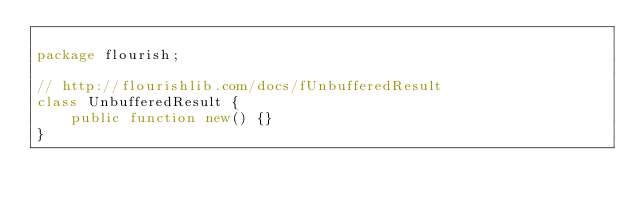<code> <loc_0><loc_0><loc_500><loc_500><_Haxe_>
package flourish;

// http://flourishlib.com/docs/fUnbufferedResult
class UnbufferedResult {
    public function new() {}
}
</code> 